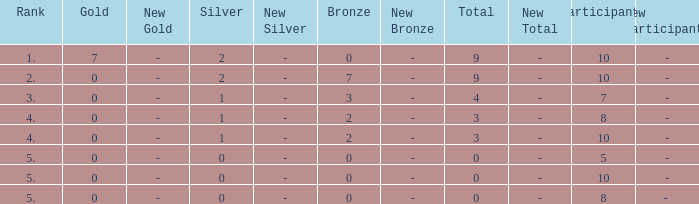What is listed as the highest Gold that also has a Silver that's smaller than 1, and has a Total that's smaller than 0? None. 